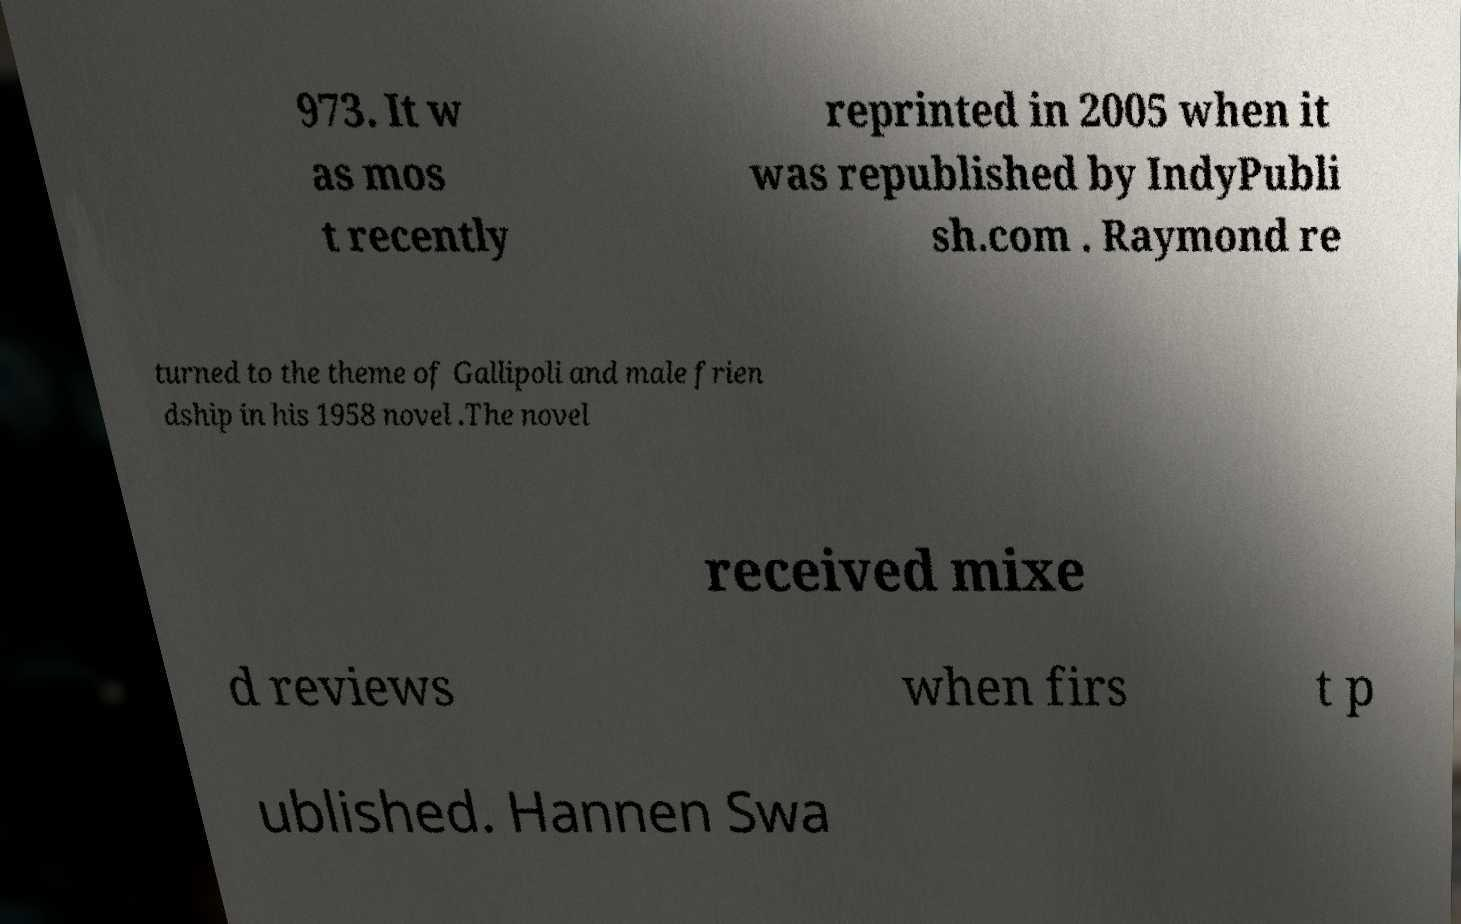Please read and relay the text visible in this image. What does it say? 973. It w as mos t recently reprinted in 2005 when it was republished by IndyPubli sh.com . Raymond re turned to the theme of Gallipoli and male frien dship in his 1958 novel .The novel received mixe d reviews when firs t p ublished. Hannen Swa 